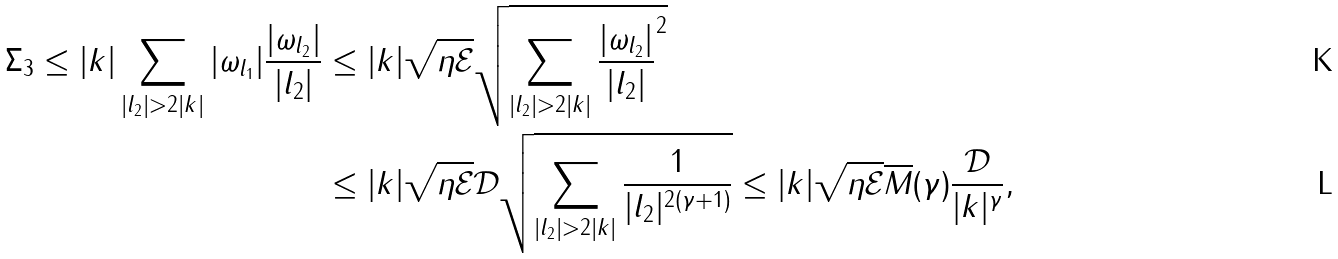Convert formula to latex. <formula><loc_0><loc_0><loc_500><loc_500>\Sigma _ { 3 } \leq | k | \sum _ { | l _ { 2 } | > 2 | k | } | \omega _ { l _ { 1 } } | \frac { | \omega _ { l _ { 2 } } | } { | l _ { 2 } | } & \leq | k | \sqrt { \eta \mathcal { E } } \sqrt { \sum _ { | l _ { 2 } | > 2 | k | } { \frac { | \omega _ { l _ { 2 } } | } { | l _ { 2 } | } } ^ { 2 } } \\ & \leq | k | \sqrt { \eta \mathcal { E } } \mathcal { D } \sqrt { \sum _ { | l _ { 2 } | > 2 | k | } \frac { 1 } { | l _ { 2 } | ^ { 2 ( \gamma + 1 ) } } } \leq | k | \sqrt { \eta \mathcal { E } } \overline { M } ( \gamma ) \frac { \mathcal { D } } { { | k | ^ { \gamma } } } ,</formula> 